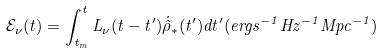Convert formula to latex. <formula><loc_0><loc_0><loc_500><loc_500>\mathcal { E } _ { \nu } ( t ) = \int _ { t _ { m } } ^ { t } L _ { \nu } ( t - t ^ { \prime } ) \dot { \tilde { \rho } } _ { \ast } ( t ^ { \prime } ) d t ^ { \prime } ( e r g s ^ { - 1 } H z ^ { - 1 } M p c ^ { - 1 } )</formula> 